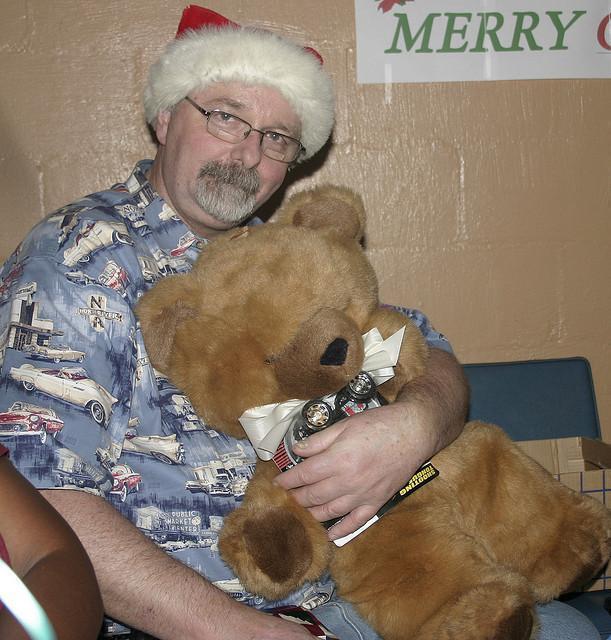How many arms are visible in this picture?
Give a very brief answer. 3. How many people can you see?
Give a very brief answer. 2. 